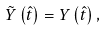Convert formula to latex. <formula><loc_0><loc_0><loc_500><loc_500>\tilde { Y } \left ( \hat { t } \right ) = Y \left ( \hat { t } \right ) ,</formula> 